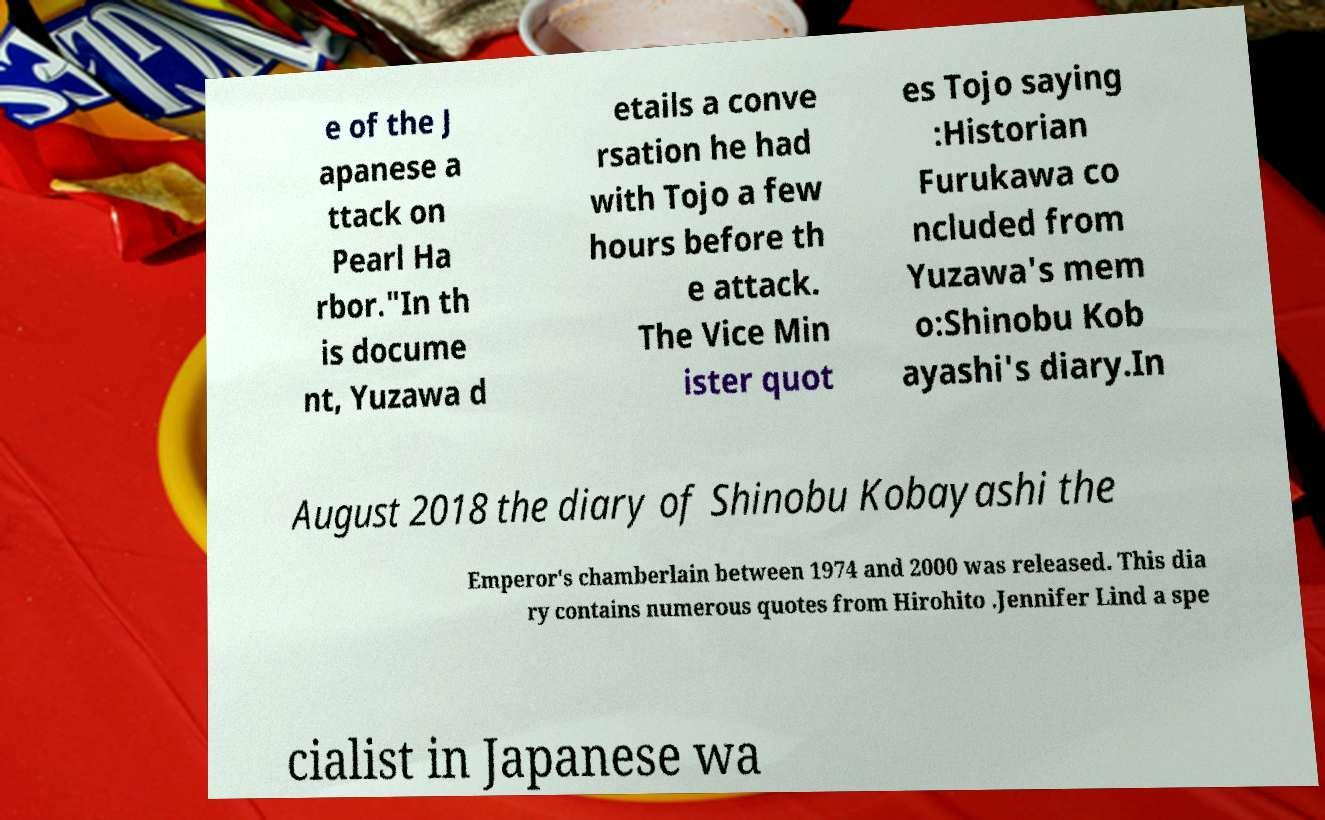Please identify and transcribe the text found in this image. e of the J apanese a ttack on Pearl Ha rbor."In th is docume nt, Yuzawa d etails a conve rsation he had with Tojo a few hours before th e attack. The Vice Min ister quot es Tojo saying :Historian Furukawa co ncluded from Yuzawa's mem o:Shinobu Kob ayashi's diary.In August 2018 the diary of Shinobu Kobayashi the Emperor's chamberlain between 1974 and 2000 was released. This dia ry contains numerous quotes from Hirohito .Jennifer Lind a spe cialist in Japanese wa 